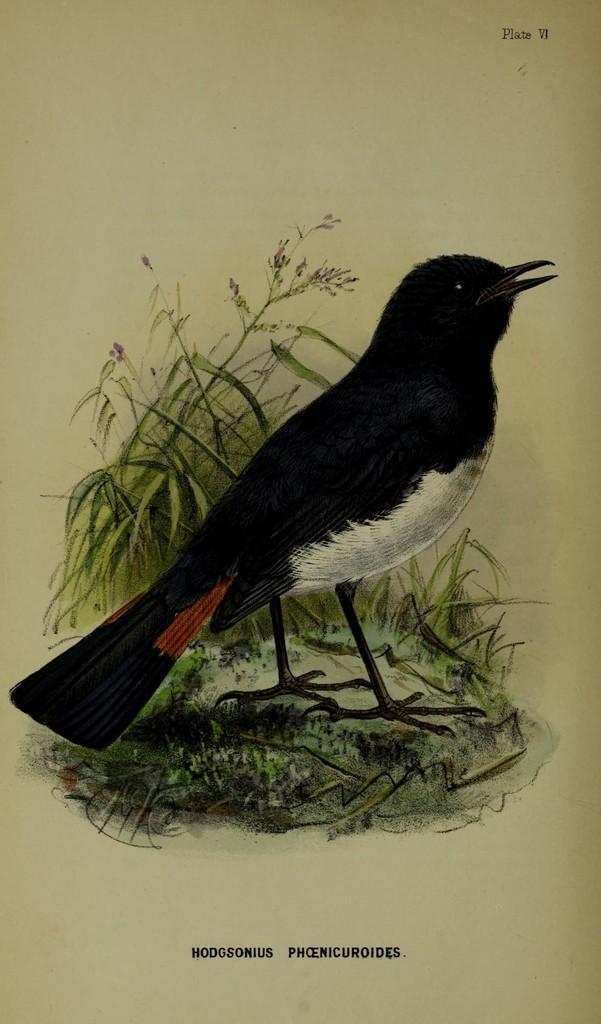Please provide a concise description of this image. In this image, we can see a poster with some images and text. 